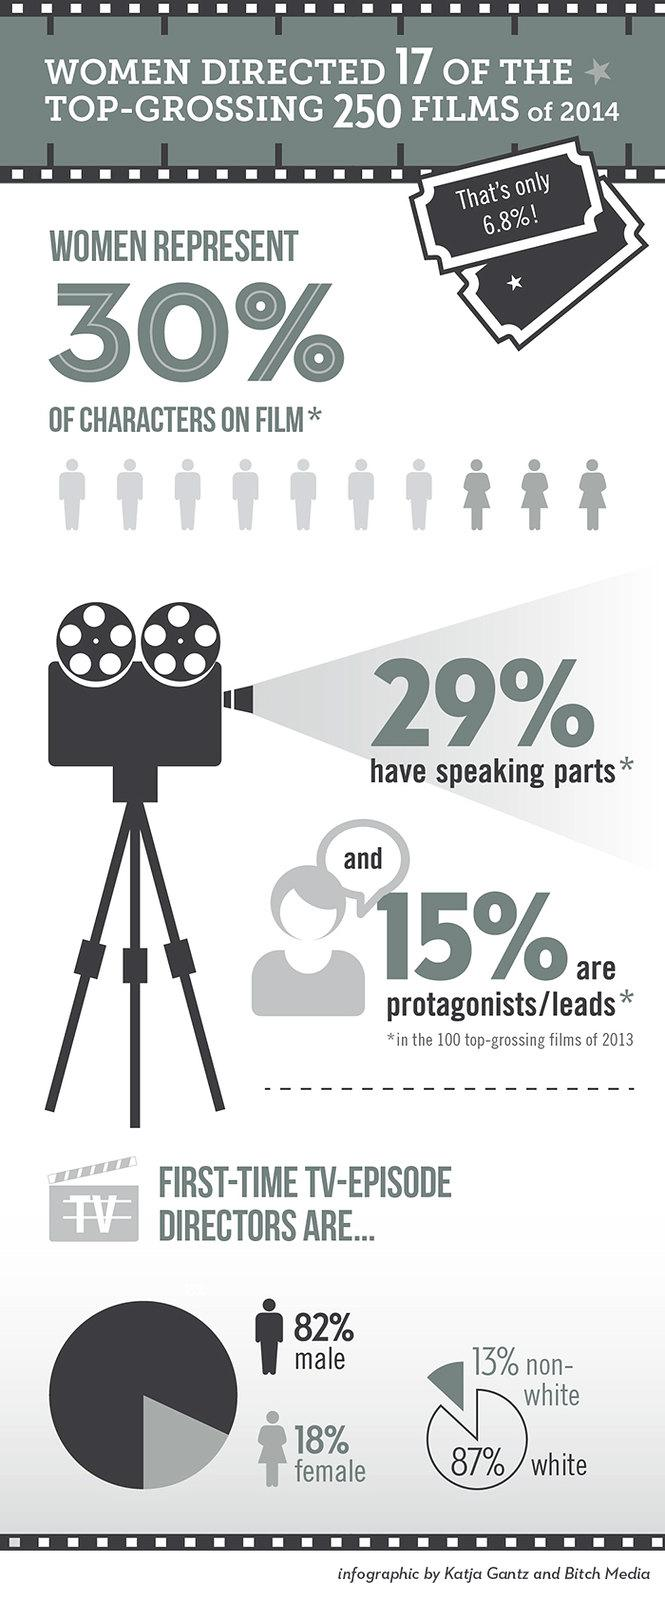Highlight a few significant elements in this photo. In 2014, a significant percentage of first-time TV-episode directors who were non-white were represented in the industry, with 13% of the total number of directors being non-white. In 2013, only 15% of the lead roles in the 100 top-grossing films were played by women. In 2014, the percentage of first-time TV-episode directors who were male was 82%. In the 100 top-grossing films of 2013, only 29% of speaking parts went to women. In 2014, it was found that only 18% of first-time TV-episode directors were females. 